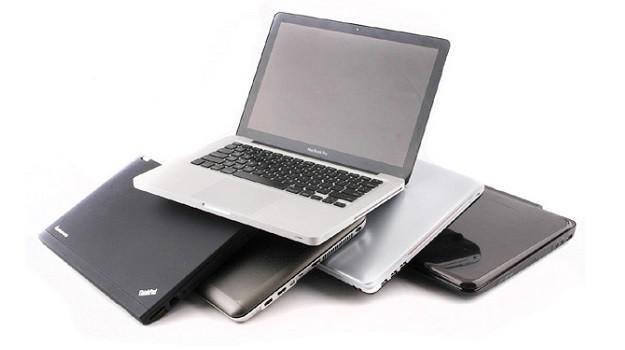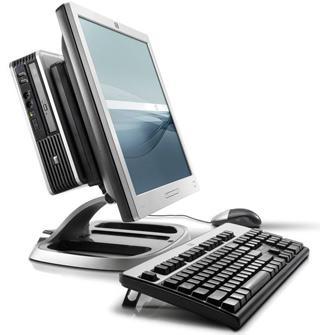The first image is the image on the left, the second image is the image on the right. Given the left and right images, does the statement "there is a pile of laptops in the image on the left, and all visible screens are dark" hold true? Answer yes or no. Yes. The first image is the image on the left, the second image is the image on the right. Considering the images on both sides, is "There is a black laptop that is opened." valid? Answer yes or no. No. 